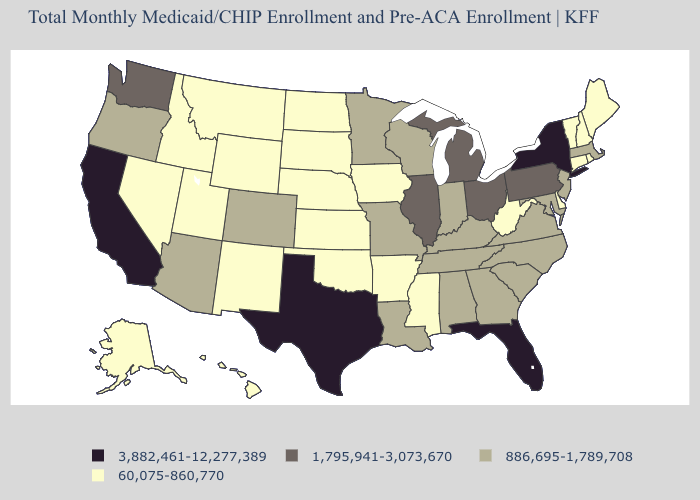What is the lowest value in states that border Illinois?
Keep it brief. 60,075-860,770. Among the states that border Utah , which have the highest value?
Quick response, please. Arizona, Colorado. What is the lowest value in the USA?
Short answer required. 60,075-860,770. What is the value of Florida?
Quick response, please. 3,882,461-12,277,389. What is the lowest value in states that border Pennsylvania?
Quick response, please. 60,075-860,770. Among the states that border Delaware , which have the highest value?
Write a very short answer. Pennsylvania. What is the lowest value in the USA?
Give a very brief answer. 60,075-860,770. Name the states that have a value in the range 886,695-1,789,708?
Concise answer only. Alabama, Arizona, Colorado, Georgia, Indiana, Kentucky, Louisiana, Maryland, Massachusetts, Minnesota, Missouri, New Jersey, North Carolina, Oregon, South Carolina, Tennessee, Virginia, Wisconsin. Name the states that have a value in the range 1,795,941-3,073,670?
Concise answer only. Illinois, Michigan, Ohio, Pennsylvania, Washington. Among the states that border Washington , does Idaho have the highest value?
Short answer required. No. Does Georgia have the lowest value in the South?
Be succinct. No. What is the value of New Jersey?
Be succinct. 886,695-1,789,708. What is the lowest value in the USA?
Give a very brief answer. 60,075-860,770. What is the lowest value in the Northeast?
Concise answer only. 60,075-860,770. Among the states that border New York , does Connecticut have the lowest value?
Concise answer only. Yes. 